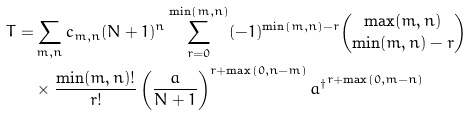Convert formula to latex. <formula><loc_0><loc_0><loc_500><loc_500>T = & \sum _ { m , n } c _ { m , n } ( N + 1 ) ^ { n } \sum _ { r = 0 } ^ { \min ( m , n ) } ( - 1 ) ^ { \min ( m , n ) - r } { \max ( m , n ) \choose \min ( m , n ) - r } \\ & \times \frac { \min ( m , n ) ! } { r ! } \left ( \frac { a } { N + 1 } \right ) ^ { r + \max ( 0 , n - m ) } { a ^ { \dag } } ^ { r + \max ( 0 , m - n ) }</formula> 